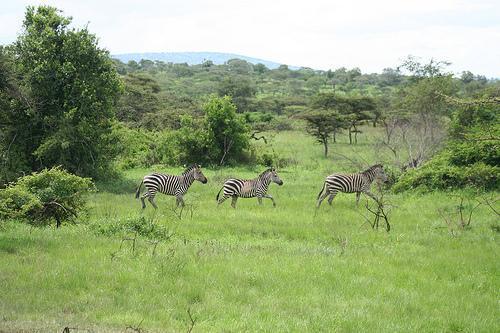How many zebras are there?
Give a very brief answer. 3. 